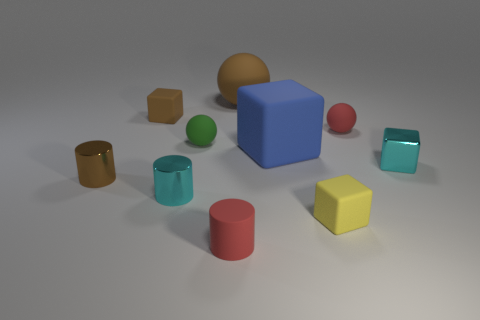Subtract 1 cubes. How many cubes are left? 3 Subtract all blocks. How many objects are left? 6 Add 2 green objects. How many green objects exist? 3 Subtract 1 blue blocks. How many objects are left? 9 Subtract all cylinders. Subtract all blue matte objects. How many objects are left? 6 Add 2 brown matte blocks. How many brown matte blocks are left? 3 